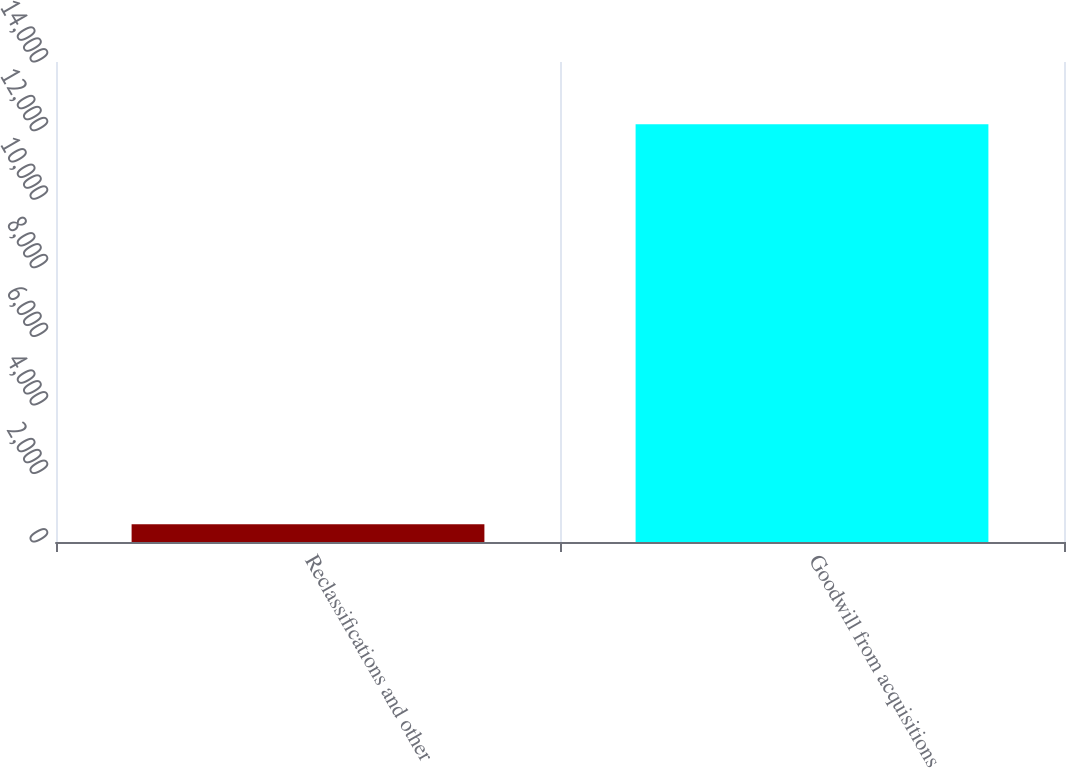Convert chart to OTSL. <chart><loc_0><loc_0><loc_500><loc_500><bar_chart><fcel>Reclassifications and other<fcel>Goodwill from acquisitions<nl><fcel>516<fcel>12181<nl></chart> 